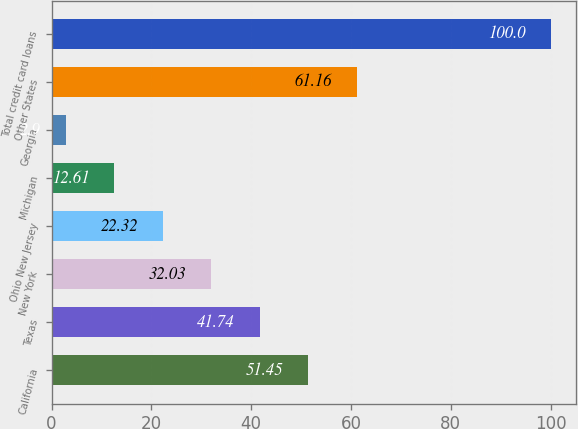<chart> <loc_0><loc_0><loc_500><loc_500><bar_chart><fcel>California<fcel>Texas<fcel>New York<fcel>Ohio New Jersey<fcel>Michigan<fcel>Georgia<fcel>Other States<fcel>Total credit card loans<nl><fcel>51.45<fcel>41.74<fcel>32.03<fcel>22.32<fcel>12.61<fcel>2.9<fcel>61.16<fcel>100<nl></chart> 